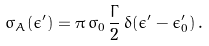Convert formula to latex. <formula><loc_0><loc_0><loc_500><loc_500>\sigma _ { A } ( \epsilon ^ { \prime } ) = \pi \, \sigma _ { 0 } \, \frac { \Gamma } { 2 } \, \delta ( \epsilon ^ { \prime } - \epsilon ^ { \prime } _ { 0 } ) \, .</formula> 